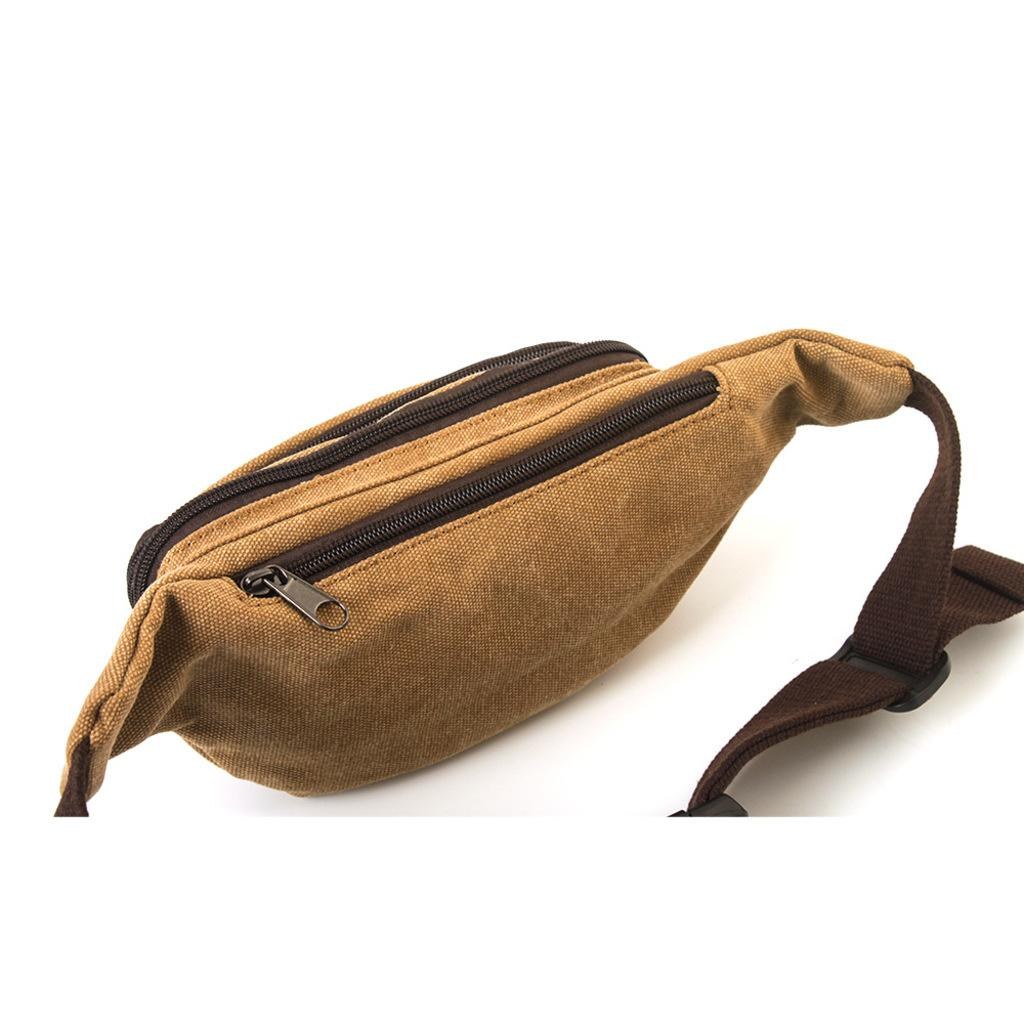What color is the waist bag in the image? The waist bag is brown in color. How many zippers are on the waist bag? There are two zippers on the waist bag. What type of guitar is the scarecrow playing in the image? There is no scarecrow or guitar present in the image; it only features a brown waist bag with two zippers. 